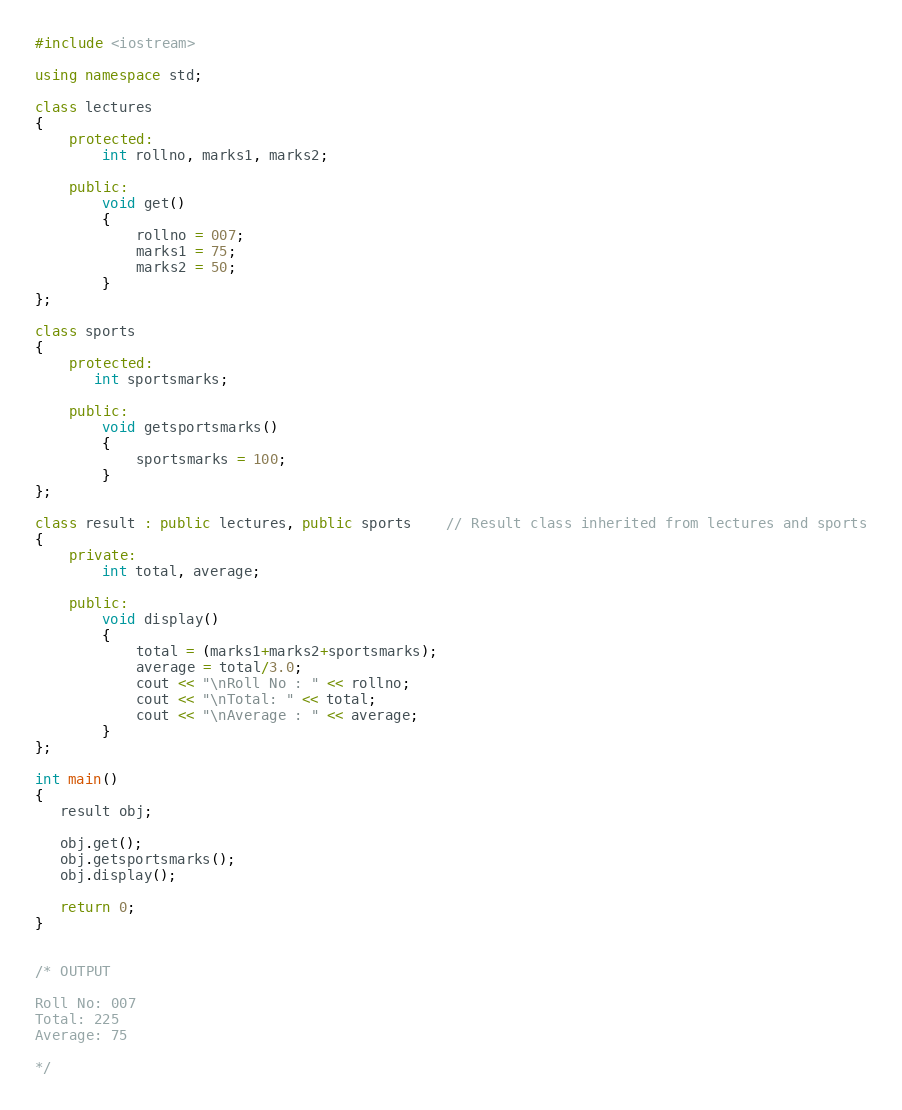<code> <loc_0><loc_0><loc_500><loc_500><_C++_>#include <iostream>

using namespace std;

class lectures
{
    protected:
        int rollno, marks1, marks2;

    public:
        void get()
        {
            rollno = 007;
            marks1 = 75;
		    marks2 = 50;
        }
};

class sports
{
    protected:
       int sportsmarks;

    public:
        void getsportsmarks()
        {
            sportsmarks = 100;
        }
};

class result : public lectures, public sports    // Result class inherited from lectures and sports
{
    private:
        int total, average;

    public:
        void display()
        {
            total = (marks1+marks2+sportsmarks);
            average = total/3.0;
            cout << "\nRoll No : " << rollno;
            cout << "\nTotal: " << total;
            cout << "\nAverage : " << average;
        }
};

int main()
{
   result obj;

   obj.get();
   obj.getsportsmarks();
   obj.display();

   return 0;
}


/* OUTPUT

Roll No: 007
Total: 225
Average: 75

*/
</code> 